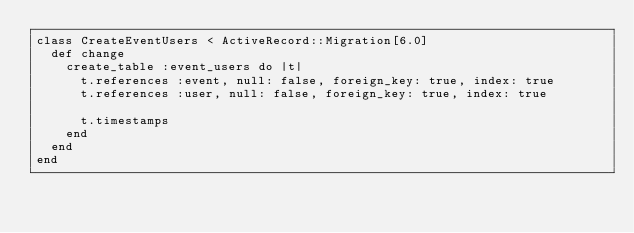Convert code to text. <code><loc_0><loc_0><loc_500><loc_500><_Ruby_>class CreateEventUsers < ActiveRecord::Migration[6.0]
  def change
    create_table :event_users do |t|
      t.references :event, null: false, foreign_key: true, index: true
      t.references :user, null: false, foreign_key: true, index: true

      t.timestamps
    end
  end
end
</code> 